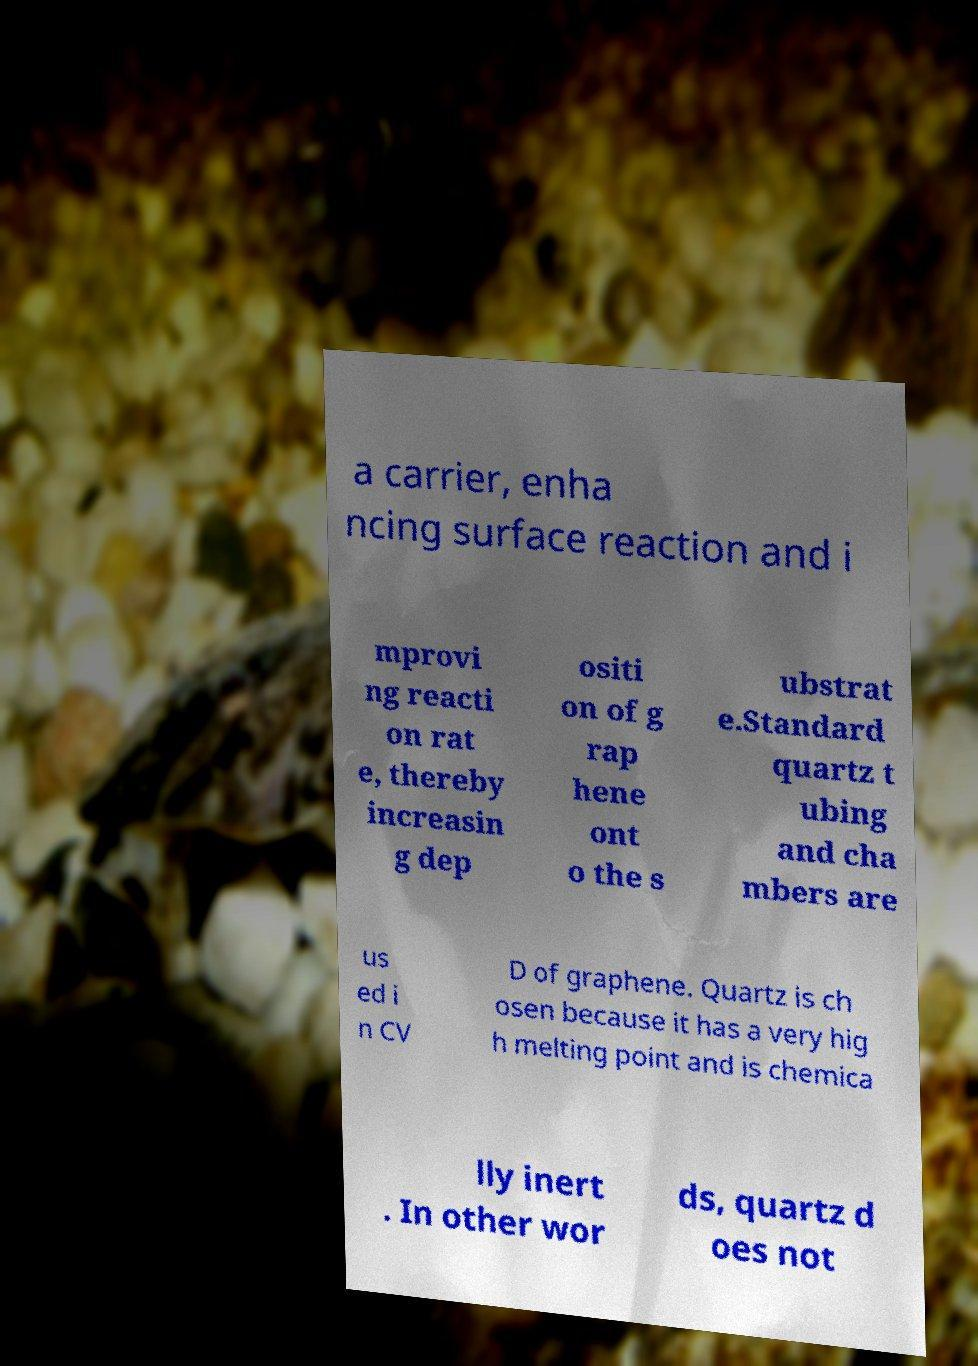Please identify and transcribe the text found in this image. a carrier, enha ncing surface reaction and i mprovi ng reacti on rat e, thereby increasin g dep ositi on of g rap hene ont o the s ubstrat e.Standard quartz t ubing and cha mbers are us ed i n CV D of graphene. Quartz is ch osen because it has a very hig h melting point and is chemica lly inert . In other wor ds, quartz d oes not 